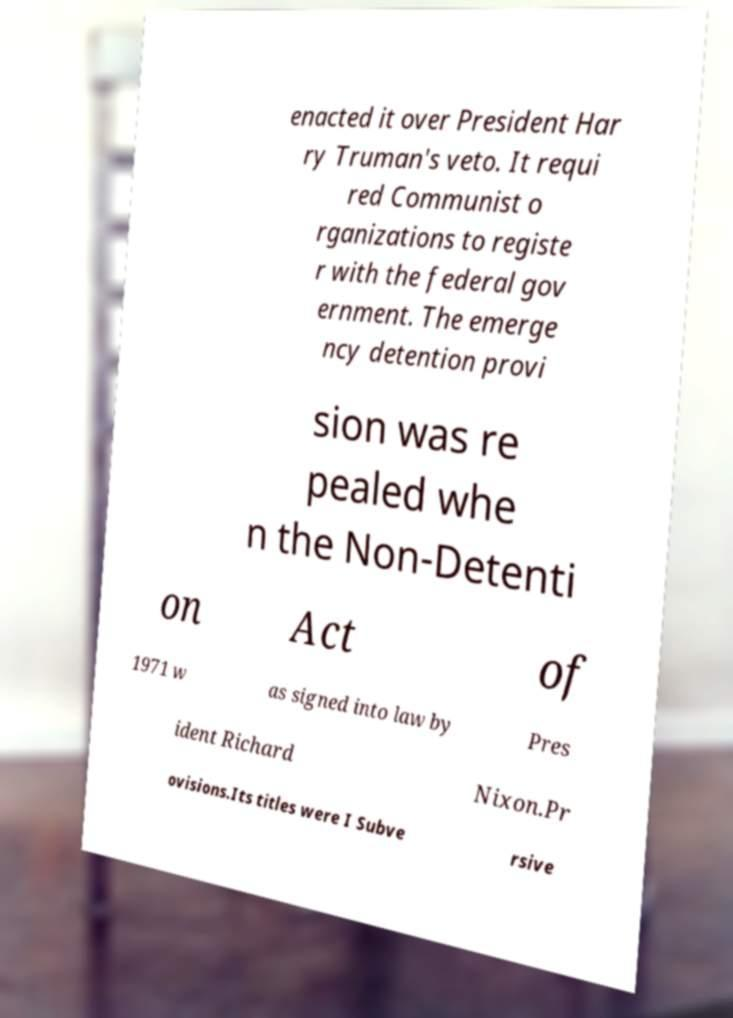Can you read and provide the text displayed in the image?This photo seems to have some interesting text. Can you extract and type it out for me? enacted it over President Har ry Truman's veto. It requi red Communist o rganizations to registe r with the federal gov ernment. The emerge ncy detention provi sion was re pealed whe n the Non-Detenti on Act of 1971 w as signed into law by Pres ident Richard Nixon.Pr ovisions.Its titles were I Subve rsive 